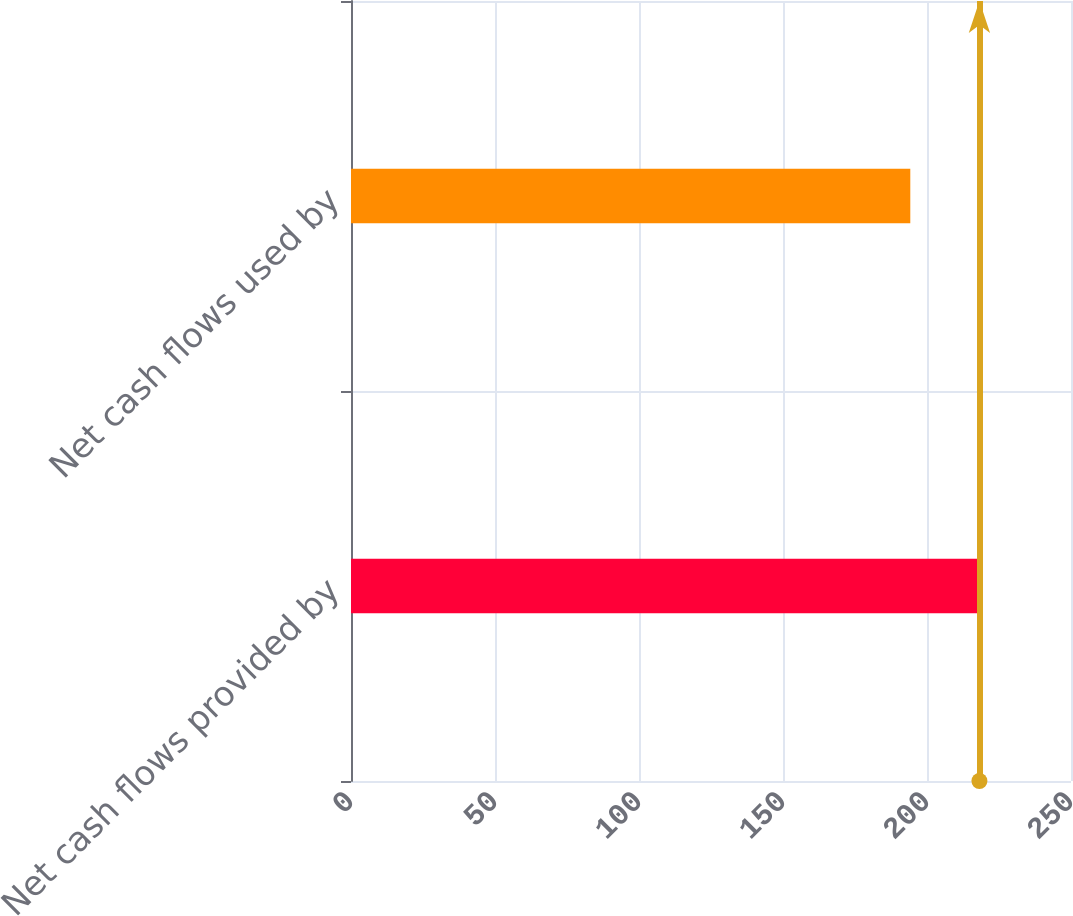Convert chart to OTSL. <chart><loc_0><loc_0><loc_500><loc_500><bar_chart><fcel>Net cash flows provided by<fcel>Net cash flows used by<nl><fcel>218.2<fcel>194.2<nl></chart> 